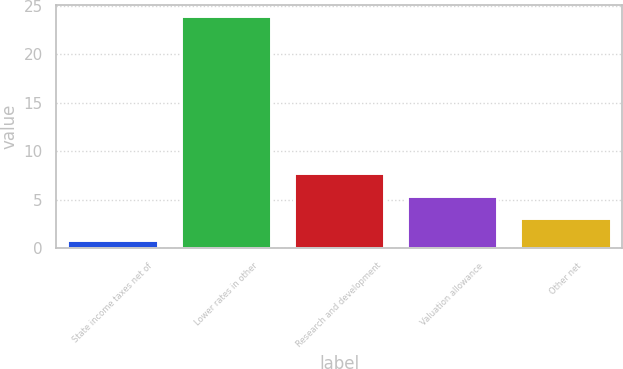<chart> <loc_0><loc_0><loc_500><loc_500><bar_chart><fcel>State income taxes net of<fcel>Lower rates in other<fcel>Research and development<fcel>Valuation allowance<fcel>Other net<nl><fcel>0.8<fcel>23.9<fcel>7.73<fcel>5.42<fcel>3.11<nl></chart> 